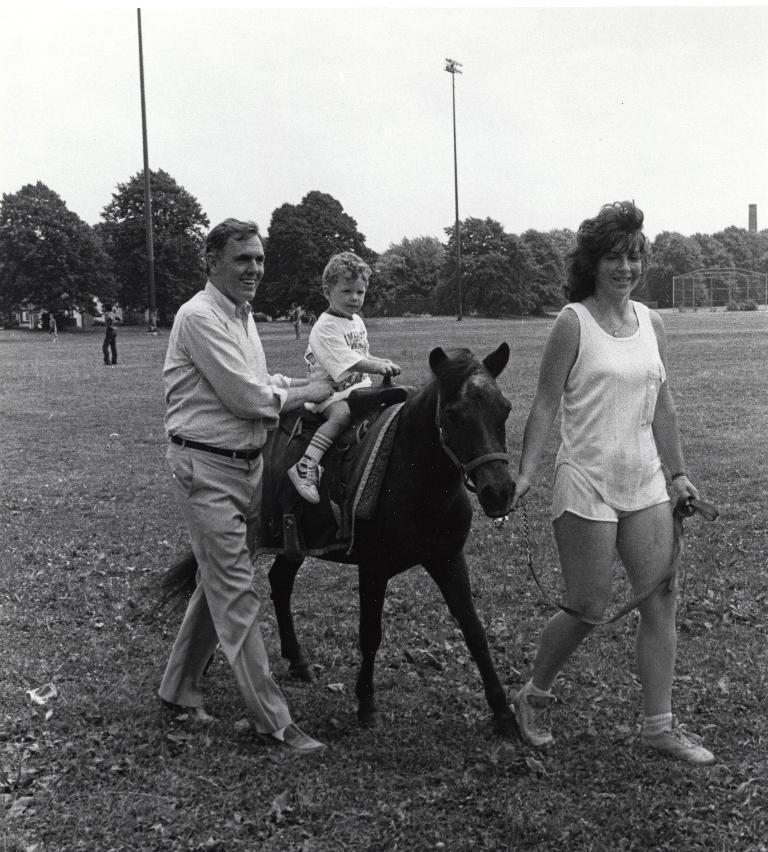Can you describe this image briefly? This picture is clicked in ground or outside the city. Here, we see man holding baby, is laughing and the baby is riding horse. Woman on the right corner of this picture wearing white dress is catching the rope of the horse. Behind them, we see the man standing in the ground and behind him, we see street lights, electric poles and behind that, we see sky and trees. 